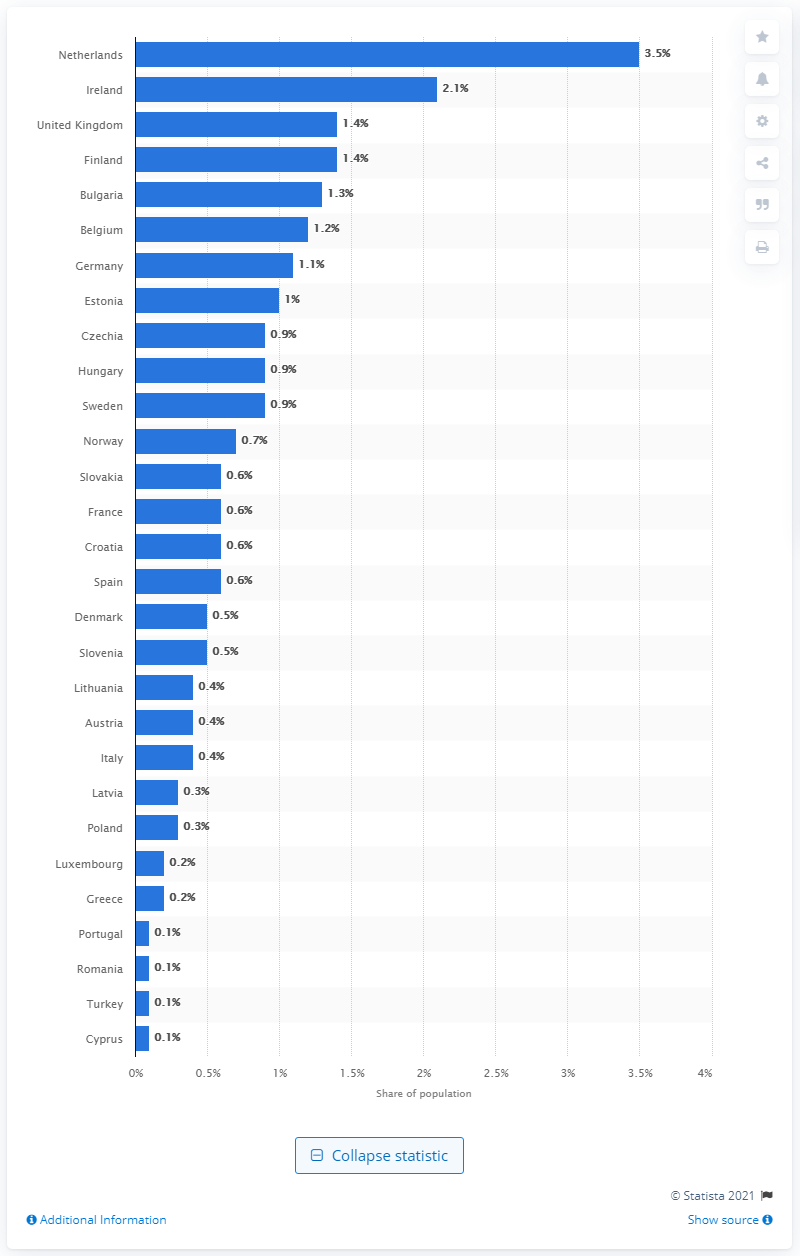Identify some key points in this picture. According to a report, 2.1% of Ireland's population uses ecstasy. 